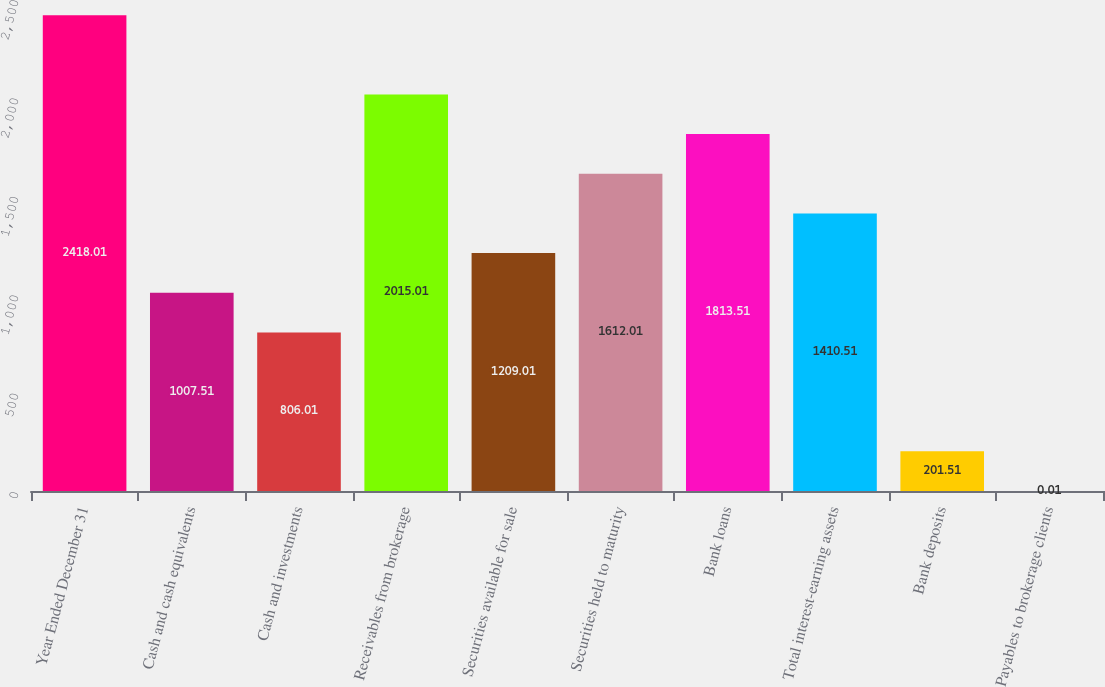Convert chart. <chart><loc_0><loc_0><loc_500><loc_500><bar_chart><fcel>Year Ended December 31<fcel>Cash and cash equivalents<fcel>Cash and investments<fcel>Receivables from brokerage<fcel>Securities available for sale<fcel>Securities held to maturity<fcel>Bank loans<fcel>Total interest-earning assets<fcel>Bank deposits<fcel>Payables to brokerage clients<nl><fcel>2418.01<fcel>1007.51<fcel>806.01<fcel>2015.01<fcel>1209.01<fcel>1612.01<fcel>1813.51<fcel>1410.51<fcel>201.51<fcel>0.01<nl></chart> 